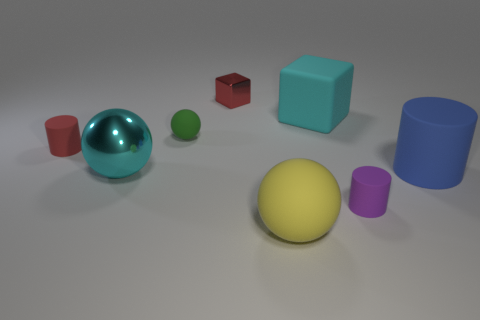What number of objects are in front of the large matte cylinder?
Give a very brief answer. 3. Is the yellow sphere made of the same material as the red object that is right of the green matte ball?
Offer a terse response. No. What size is the red object that is the same material as the large cylinder?
Make the answer very short. Small. Are there more tiny purple rubber cylinders that are behind the rubber block than rubber cylinders that are on the right side of the small red cylinder?
Provide a succinct answer. No. Are there any other big shiny objects of the same shape as the yellow thing?
Ensure brevity in your answer.  Yes. Is the size of the yellow rubber object that is on the left side of the cyan rubber block the same as the purple thing?
Your response must be concise. No. Is there a purple cylinder?
Make the answer very short. Yes. What number of things are blocks in front of the red cube or tiny yellow metallic objects?
Provide a succinct answer. 1. There is a large metallic object; is it the same color as the matte cylinder that is behind the blue cylinder?
Your response must be concise. No. Are there any yellow rubber spheres that have the same size as the red cube?
Your answer should be very brief. No. 